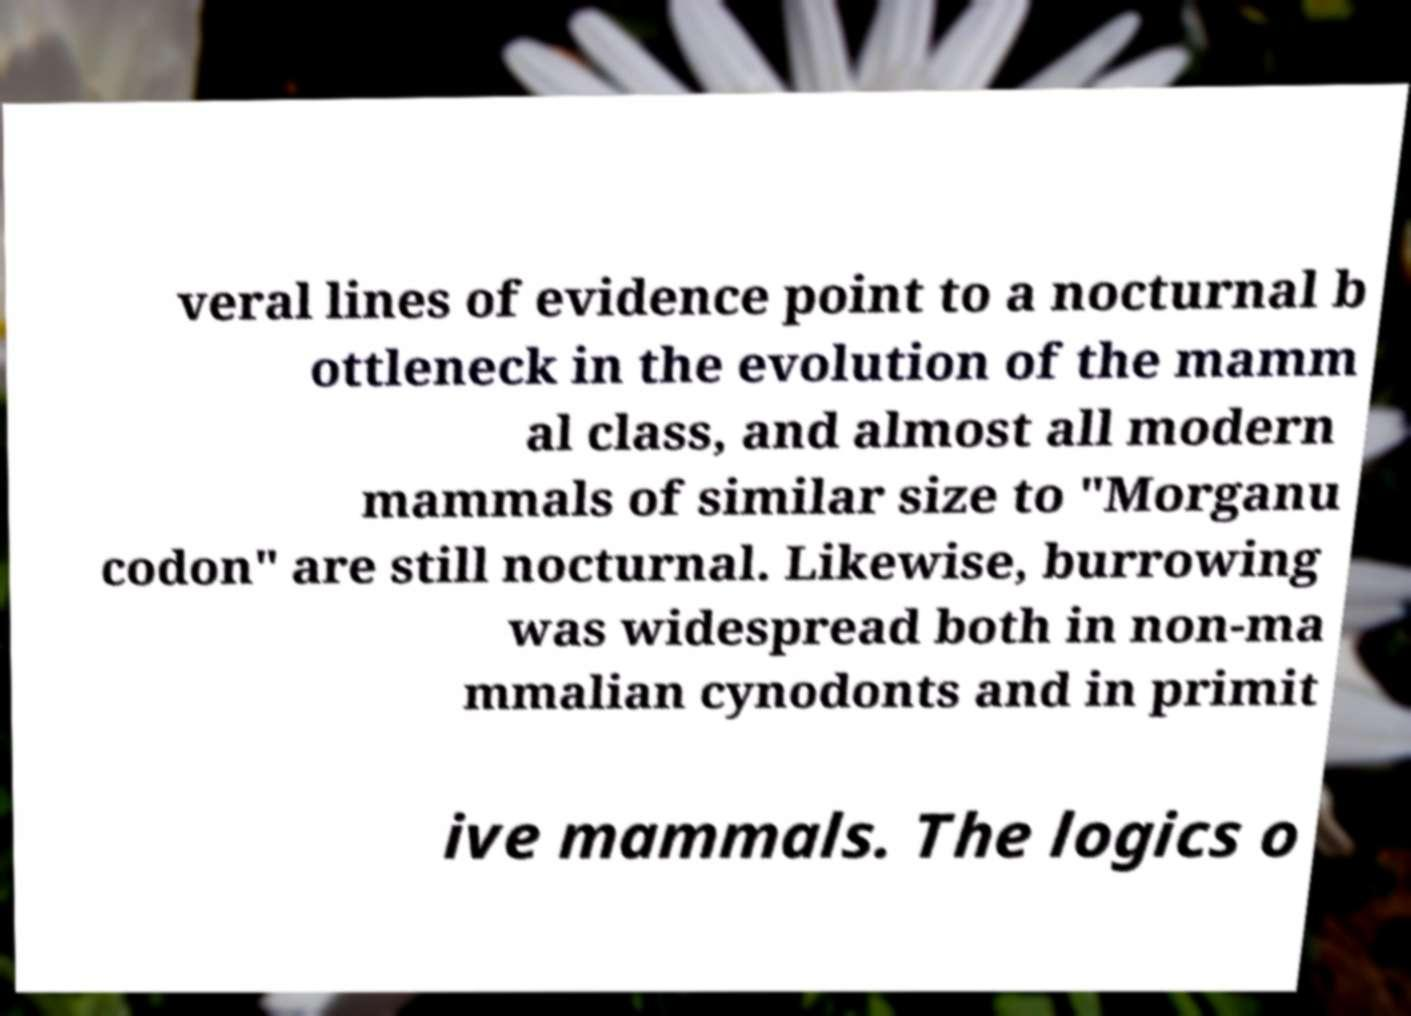Please read and relay the text visible in this image. What does it say? veral lines of evidence point to a nocturnal b ottleneck in the evolution of the mamm al class, and almost all modern mammals of similar size to "Morganu codon" are still nocturnal. Likewise, burrowing was widespread both in non-ma mmalian cynodonts and in primit ive mammals. The logics o 